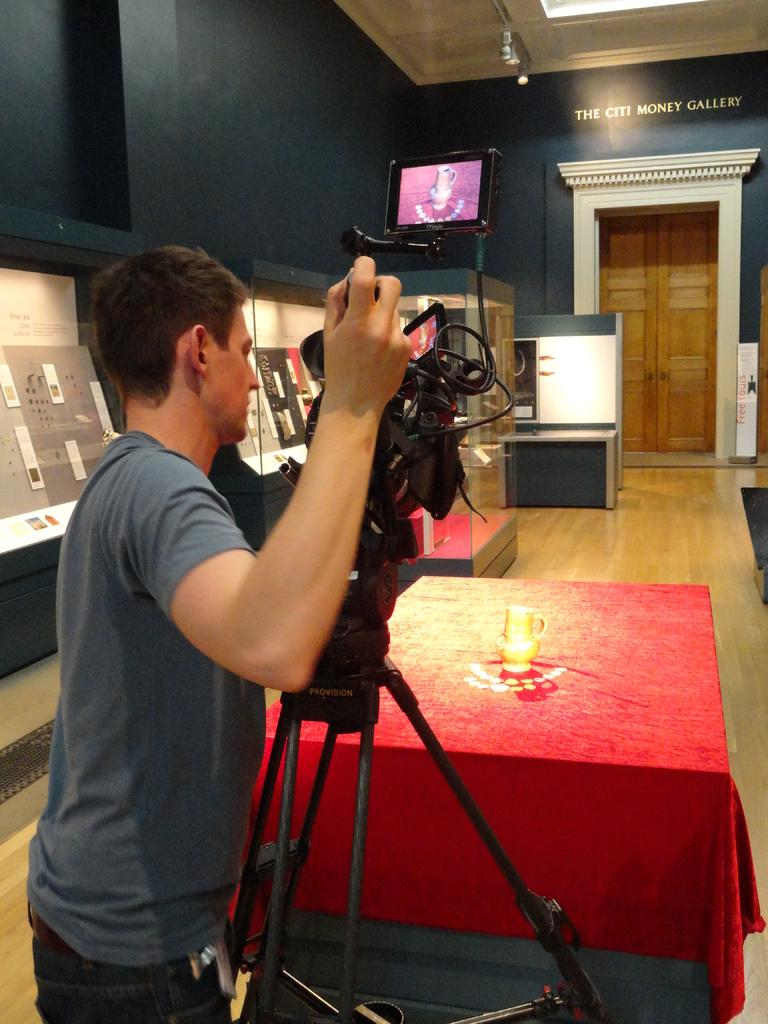What is the main subject in the center of the image? There is a person standing in the center of the image. What can be seen in the background of the image? There are posters, a door, a name board, and a wall in the background of the image. What is located at the bottom of the image? There is a table at the bottom of the image. What type of plastic is used to make the oil in the image? There is no plastic or oil present in the image. What year is depicted on the name board in the image? The provided facts do not mention any specific year on the name board, so it cannot be determined from the image. 